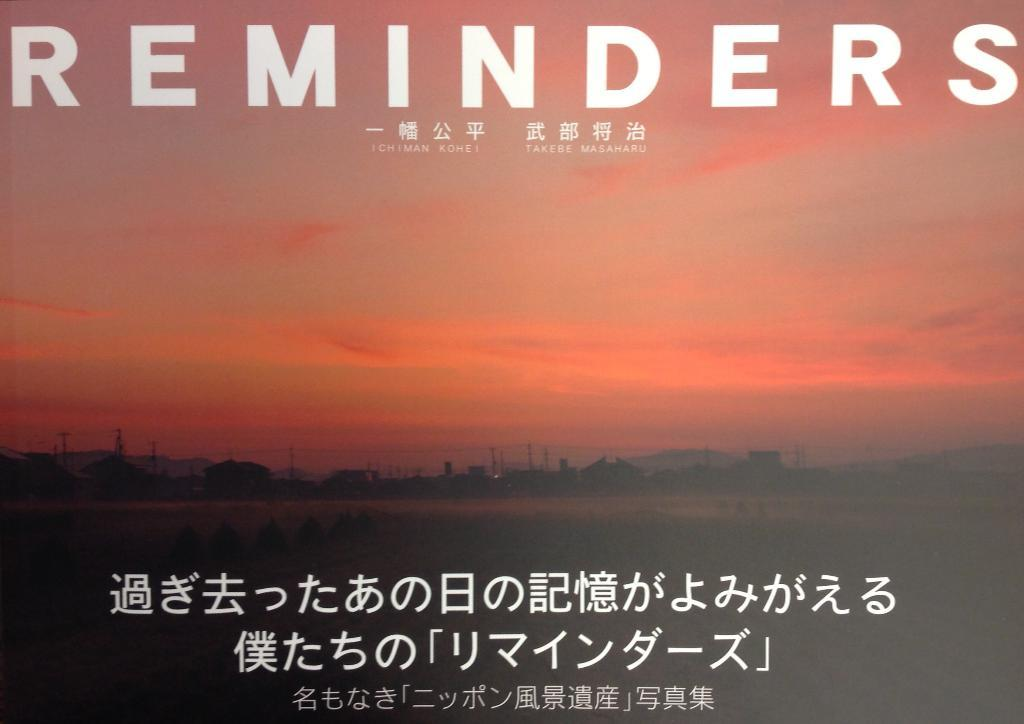Provide a one-sentence caption for the provided image. A sign with Japanese letters and the word Reminders. 